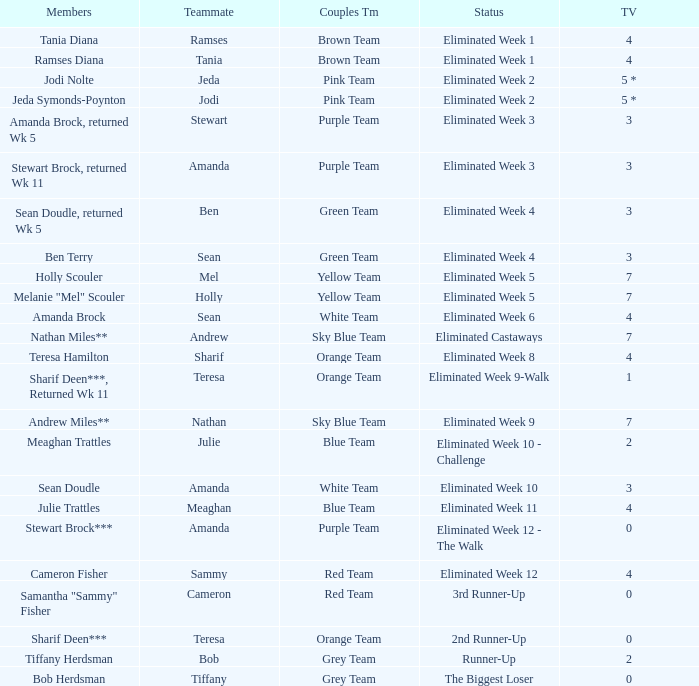What were Holly Scouler's total votes? 7.0. 